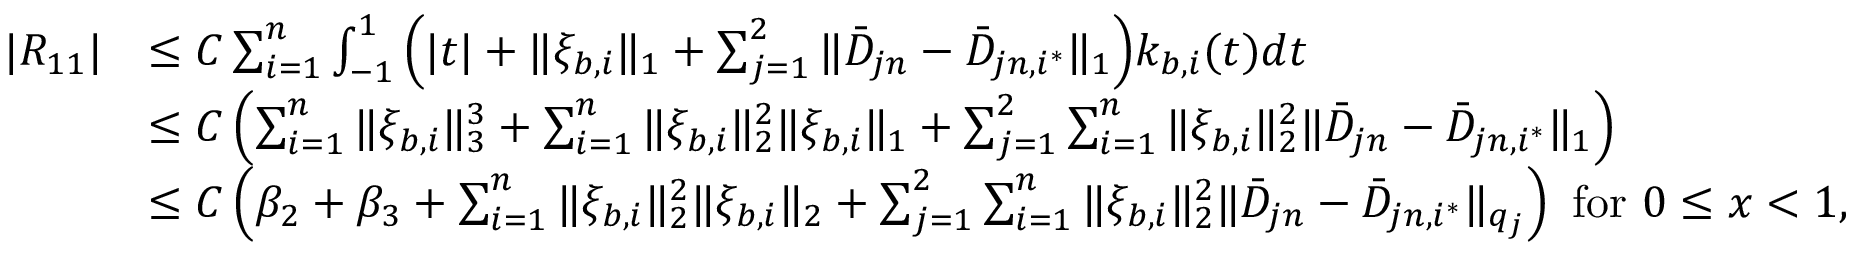<formula> <loc_0><loc_0><loc_500><loc_500>\begin{array} { r l } { | R _ { 1 1 } | } & { \leq C \sum _ { i = 1 } ^ { n } \int _ { - 1 } ^ { 1 } \left ( | t | + \| \xi _ { b , i } \| _ { 1 } + \sum _ { j = 1 } ^ { 2 } \| \bar { D } _ { j n } - \bar { D } _ { j n , i ^ { * } } \| _ { 1 } \right ) k _ { b , i } ( t ) d t } \\ & { \leq C \left ( \sum _ { i = 1 } ^ { n } \| \xi _ { b , i } \| _ { 3 } ^ { 3 } + \sum _ { i = 1 } ^ { n } \| \xi _ { b , i } \| _ { 2 } ^ { 2 } \| \xi _ { b , i } \| _ { 1 } + \sum _ { j = 1 } ^ { 2 } \sum _ { i = 1 } ^ { n } \| \xi _ { b , i } \| _ { 2 } ^ { 2 } \| \bar { D } _ { j n } - \bar { D } _ { j n , i ^ { * } } \| _ { 1 } \right ) } \\ & { \leq C \left ( \beta _ { 2 } + \beta _ { 3 } + \sum _ { i = 1 } ^ { n } \| \xi _ { b , i } \| _ { 2 } ^ { 2 } \| \xi _ { b , i } \| _ { 2 } + \sum _ { j = 1 } ^ { 2 } \sum _ { i = 1 } ^ { n } \| \xi _ { b , i } \| _ { 2 } ^ { 2 } \| \bar { D } _ { j n } - \bar { D } _ { j n , i ^ { * } } \| _ { q _ { j } } \right ) f o r 0 \leq x < 1 , } \end{array}</formula> 